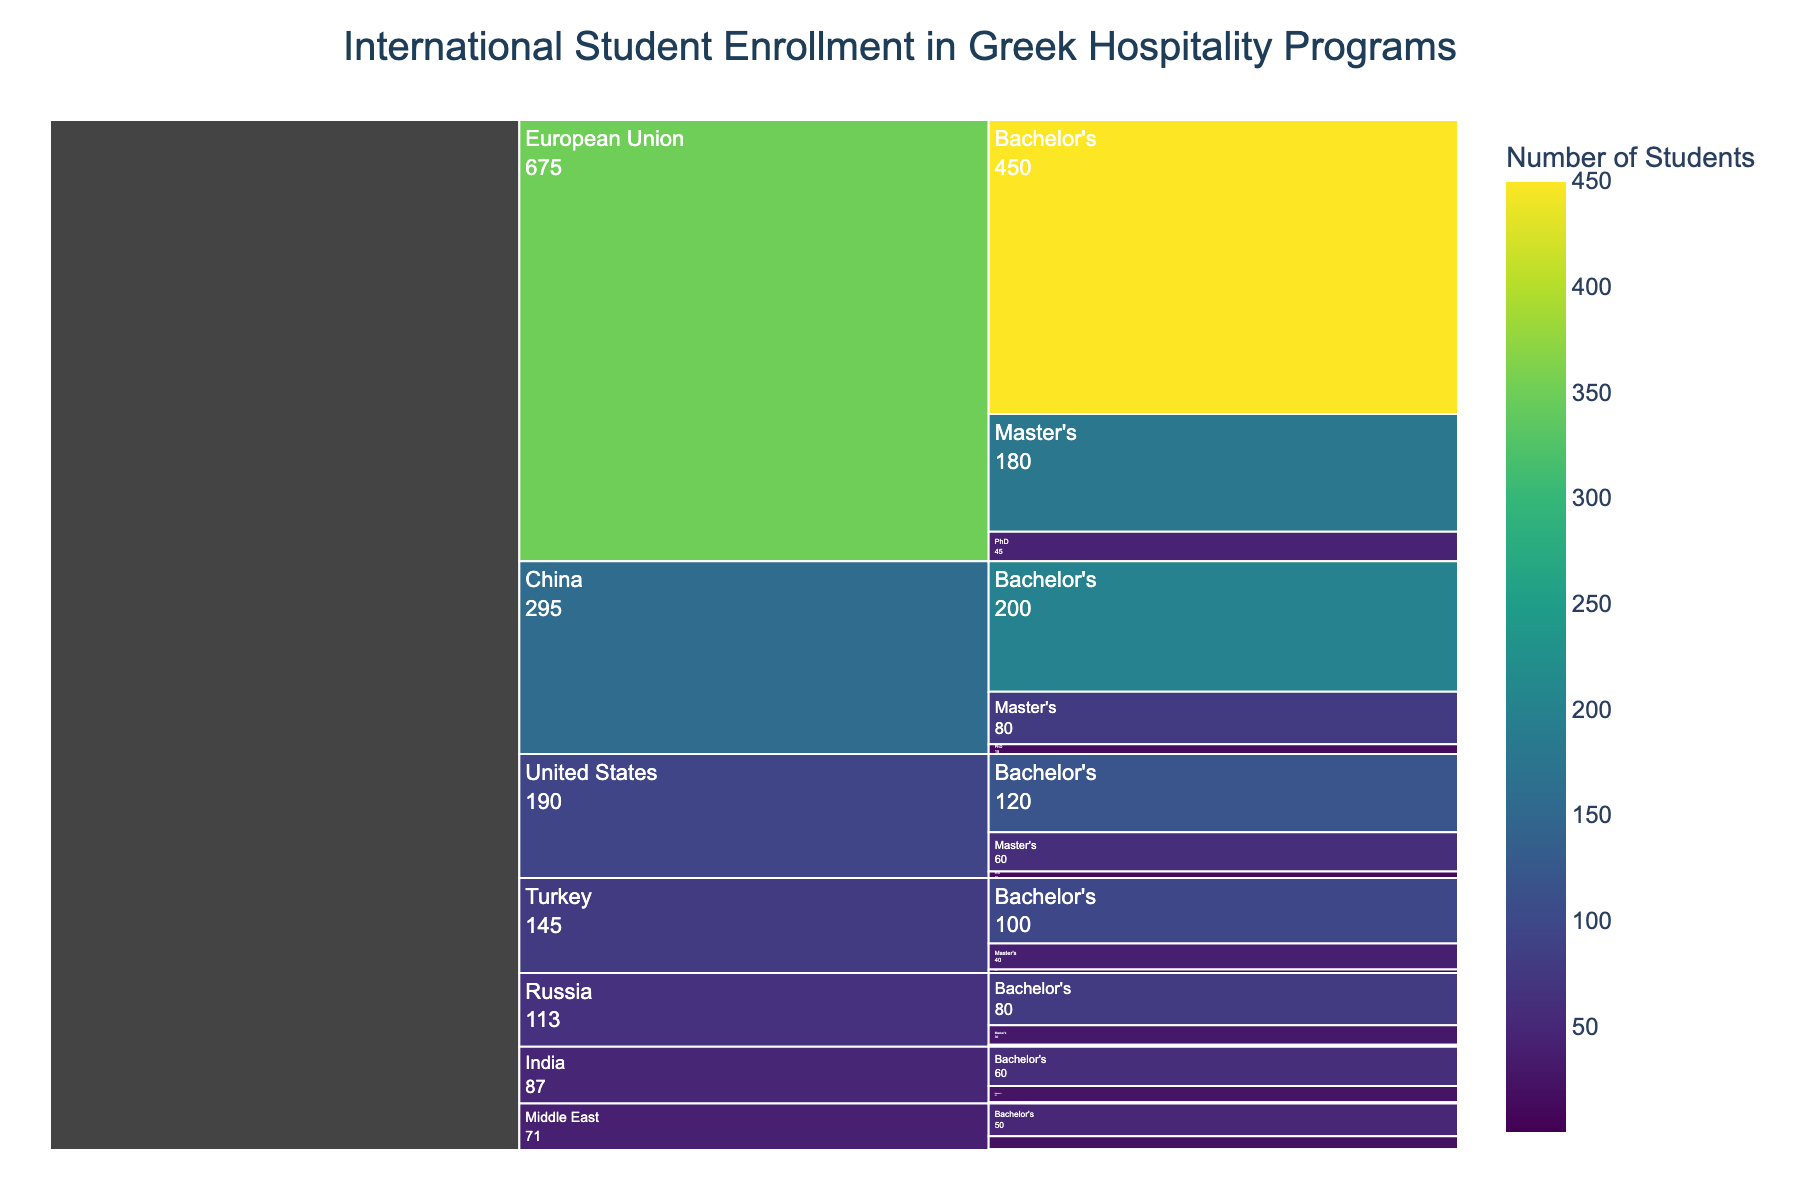What is the title of the Icicle Chart? The title is usually displayed at the top of the chart. In this case, the title clearly states the main topic being visualized.
Answer: International Student Enrollment in Greek Hospitality Programs How many students from the European Union are enrolled in Master's programs? Look for the section of the chart representing the European Union and find the part that corresponds to Master's programs.
Answer: 180 Which country has the highest number of Bachelor's students enrolled? Identify all the countries and check the values associated with the Bachelor's level for each. The highest value indicates the country.
Answer: European Union What is the total number of students enrolled from China? Sum the number of students from China across Bachelor's, Master's, and PhD levels. The chart gives these values directly.
Answer: 295 Compare the number of Master's students from the European Union and the United States. Which is higher and by how much? Subtract the number of Master's students in the United States from those in the European Union. The chart provides the exact numbers for each level and country.
Answer: European Union is higher by 120 (180 - 60) How many PhD students are there in total? Sum the number of PhD students from all countries. You need to find and add each country's PhD student count as shown in the chart.
Answer: 81 What percentage of students from India are pursuing Bachelor's degrees? Divide the number of Bachelor's students from India by the total number of students from India, then multiply by 100 to convert to a percentage.
Answer: 70.59% Identify the country with the smallest number of total students and specify the number. Sum the students across all degree levels for each country and find the minimum. The chart provides all necessary data.
Answer: Middle East with 71 students Which level of education has the fewest number of students from Turkey? Check the number of students at each educational level for Turkey. Compare these values to find the smallest one.
Answer: PhD Is the number of Master's students from China greater than, less than, or equal to the number of Bachelor's students from the United States? Compare the two specific values given in the chart for China (Master's) and the United States (Bachelor's).
Answer: Less than 